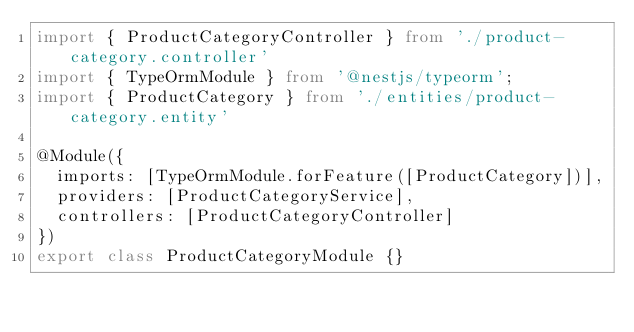<code> <loc_0><loc_0><loc_500><loc_500><_TypeScript_>import { ProductCategoryController } from './product-category.controller'
import { TypeOrmModule } from '@nestjs/typeorm';
import { ProductCategory } from './entities/product-category.entity'

@Module({
  imports: [TypeOrmModule.forFeature([ProductCategory])],
  providers: [ProductCategoryService],
  controllers: [ProductCategoryController]
})
export class ProductCategoryModule {}
</code> 